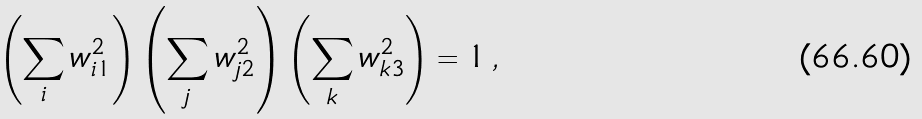<formula> <loc_0><loc_0><loc_500><loc_500>\left ( \sum _ { i } w _ { i 1 } ^ { 2 } \right ) \left ( \sum _ { j } w _ { j 2 } ^ { 2 } \right ) \left ( \sum _ { k } w _ { k 3 } ^ { 2 } \right ) = 1 \, ,</formula> 